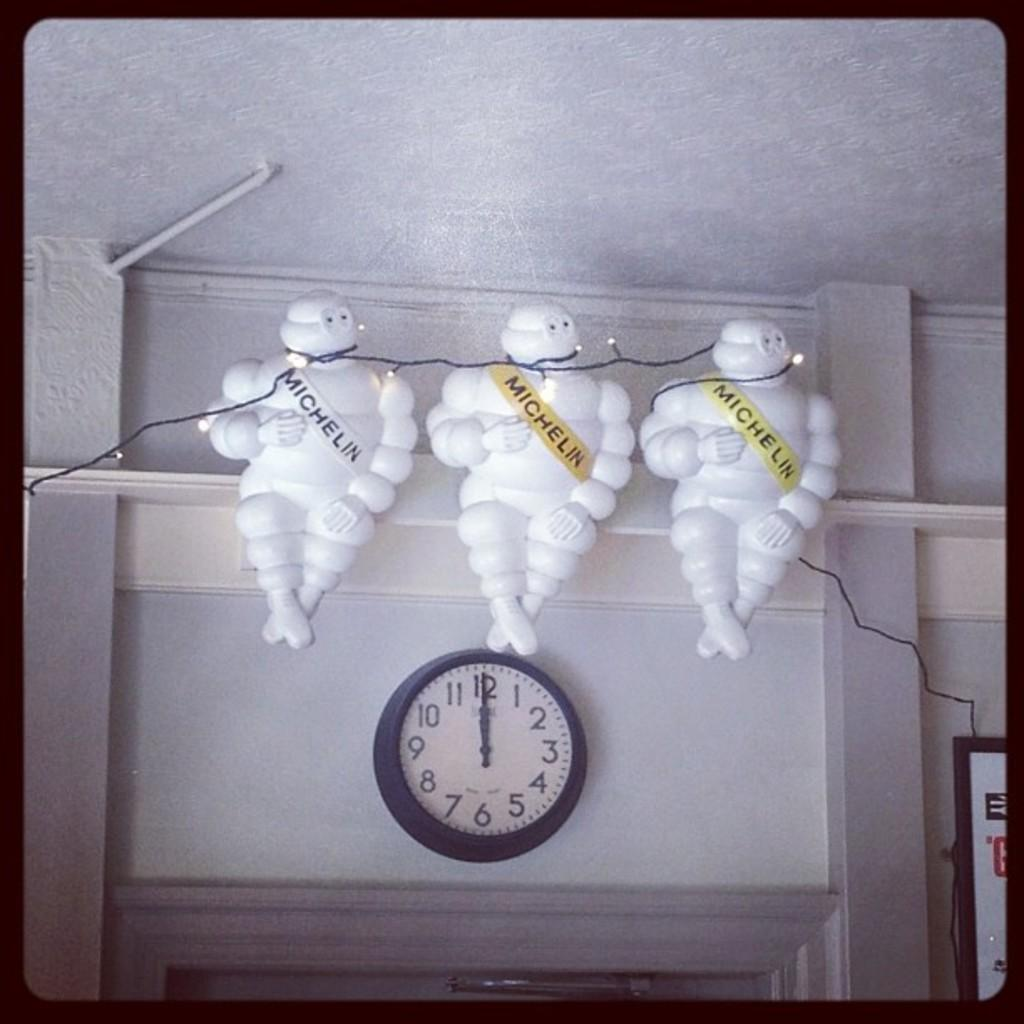<image>
Provide a brief description of the given image. Three Michelin man mascots hands on a wall above a clock 